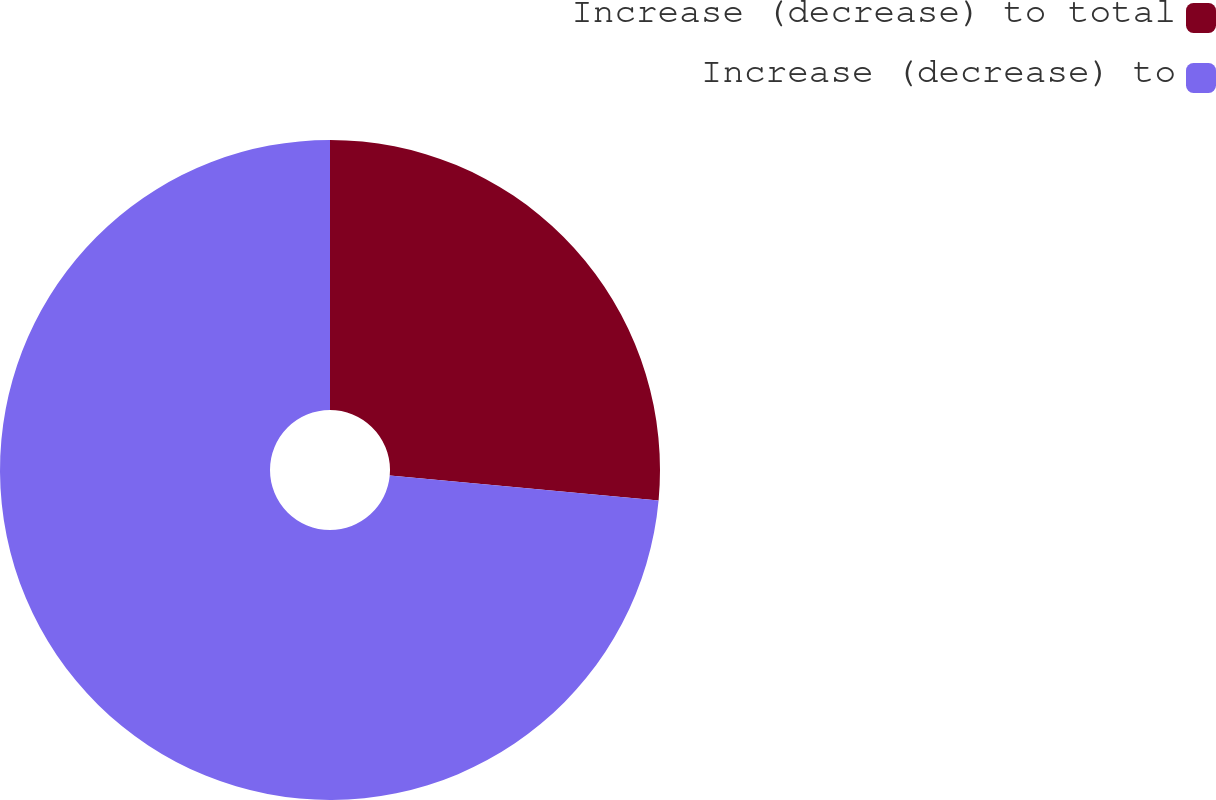Convert chart. <chart><loc_0><loc_0><loc_500><loc_500><pie_chart><fcel>Increase (decrease) to total<fcel>Increase (decrease) to<nl><fcel>26.47%<fcel>73.53%<nl></chart> 